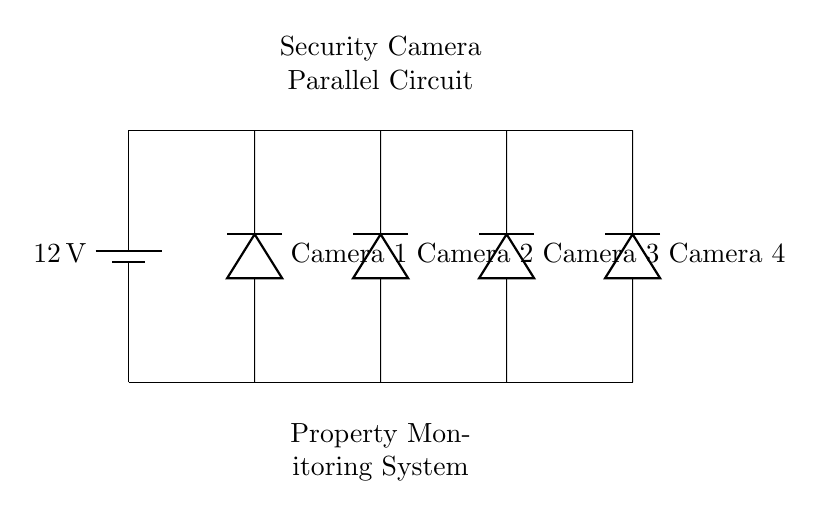What is the voltage of the power supply? The circuit shows a battery labeled with 12V, which indicates the voltage provided to the parallel circuit.
Answer: 12 volts How many security cameras are present in this circuit? There are four distinct cameras labeled in the circuit diagram, indicating that the circuit operates four security cameras.
Answer: Four What type of circuit is illustrated? The diagram specifically displays a parallel circuit as indicated by the multiple components connected to the same voltage source independently.
Answer: Parallel What does each camera represent in this circuit? Each camera is represented as a distinct load in the parallel circuit, allowing them to operate independently of one another.
Answer: Load If one camera fails, how does it affect the others? In a parallel circuit, failure of one component does not affect the operation of the others, meaning the remaining cameras will continue to function normally.
Answer: No effect What is the arrangement of the cameras in the circuit? The cameras are arranged in parallel, each connected directly across the same voltage supply, allowing simultaneous operation without mutual interference.
Answer: Parallel arrangement 